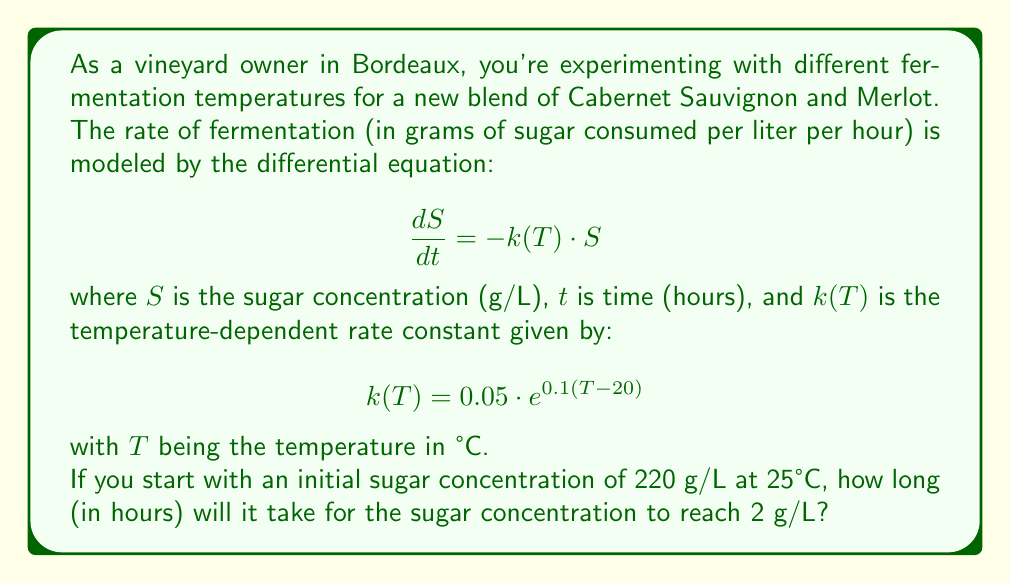Could you help me with this problem? Let's approach this problem step by step:

1) First, we need to solve the differential equation. We can separate variables:

   $$\frac{dS}{S} = -k(T) \cdot dt$$

2) Integrating both sides:

   $$\int_{S_0}^{S} \frac{dS}{S} = -k(T) \int_{0}^{t} dt$$

   $$\ln\left(\frac{S}{S_0}\right) = -k(T) \cdot t$$

3) Solving for $S$:

   $$S = S_0 \cdot e^{-k(T) \cdot t}$$

4) Now, we need to calculate $k(T)$ for T = 25°C:

   $$k(25) = 0.05 \cdot e^{0.1(25-20)} = 0.05 \cdot e^{0.5} \approx 0.0824$$

5) We can now set up our equation with the known values:

   $$2 = 220 \cdot e^{-0.0824 \cdot t}$$

6) Solving for $t$:

   $$\frac{2}{220} = e^{-0.0824 \cdot t}$$
   
   $$\ln\left(\frac{1}{110}\right) = -0.0824 \cdot t$$
   
   $$\frac{\ln(110)}{0.0824} = t$$

7) Calculating the final result:

   $$t \approx 57.15 \text{ hours}$$
Answer: It will take approximately 57.15 hours for the sugar concentration to reach 2 g/L. 